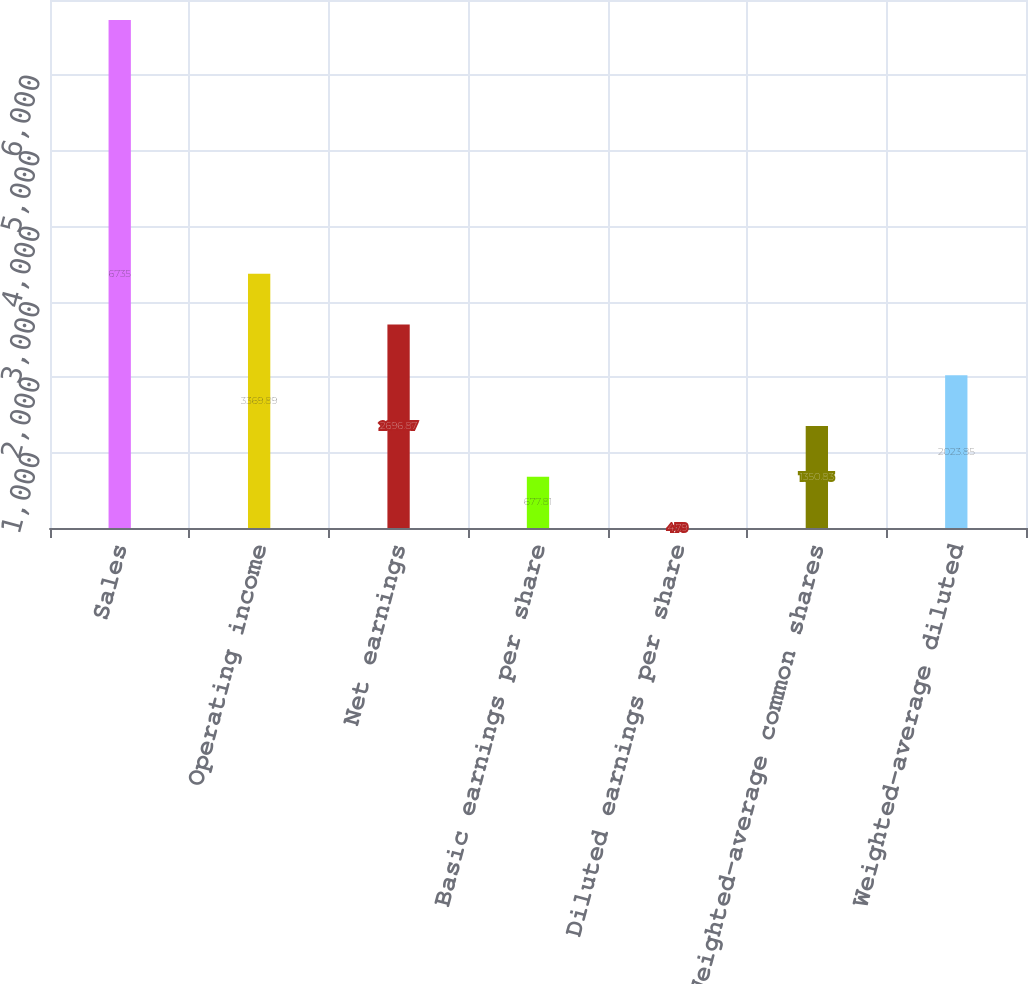Convert chart to OTSL. <chart><loc_0><loc_0><loc_500><loc_500><bar_chart><fcel>Sales<fcel>Operating income<fcel>Net earnings<fcel>Basic earnings per share<fcel>Diluted earnings per share<fcel>Weighted-average common shares<fcel>Weighted-average diluted<nl><fcel>6735<fcel>3369.89<fcel>2696.87<fcel>677.81<fcel>4.79<fcel>1350.83<fcel>2023.85<nl></chart> 